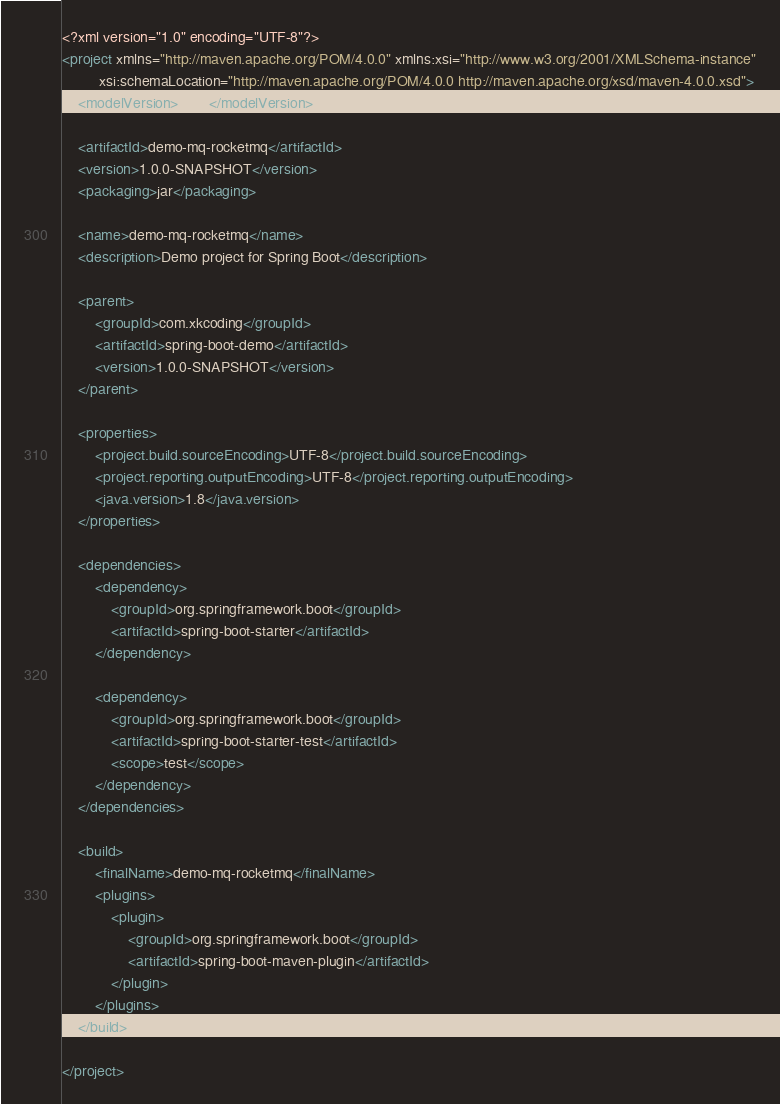Convert code to text. <code><loc_0><loc_0><loc_500><loc_500><_XML_><?xml version="1.0" encoding="UTF-8"?>
<project xmlns="http://maven.apache.org/POM/4.0.0" xmlns:xsi="http://www.w3.org/2001/XMLSchema-instance"
         xsi:schemaLocation="http://maven.apache.org/POM/4.0.0 http://maven.apache.org/xsd/maven-4.0.0.xsd">
    <modelVersion>4.0.0</modelVersion>

    <artifactId>demo-mq-rocketmq</artifactId>
    <version>1.0.0-SNAPSHOT</version>
    <packaging>jar</packaging>

    <name>demo-mq-rocketmq</name>
    <description>Demo project for Spring Boot</description>

    <parent>
        <groupId>com.xkcoding</groupId>
        <artifactId>spring-boot-demo</artifactId>
        <version>1.0.0-SNAPSHOT</version>
    </parent>

    <properties>
        <project.build.sourceEncoding>UTF-8</project.build.sourceEncoding>
        <project.reporting.outputEncoding>UTF-8</project.reporting.outputEncoding>
        <java.version>1.8</java.version>
    </properties>

    <dependencies>
        <dependency>
            <groupId>org.springframework.boot</groupId>
            <artifactId>spring-boot-starter</artifactId>
        </dependency>

        <dependency>
            <groupId>org.springframework.boot</groupId>
            <artifactId>spring-boot-starter-test</artifactId>
            <scope>test</scope>
        </dependency>
    </dependencies>

    <build>
        <finalName>demo-mq-rocketmq</finalName>
        <plugins>
            <plugin>
                <groupId>org.springframework.boot</groupId>
                <artifactId>spring-boot-maven-plugin</artifactId>
            </plugin>
        </plugins>
    </build>

</project>
</code> 